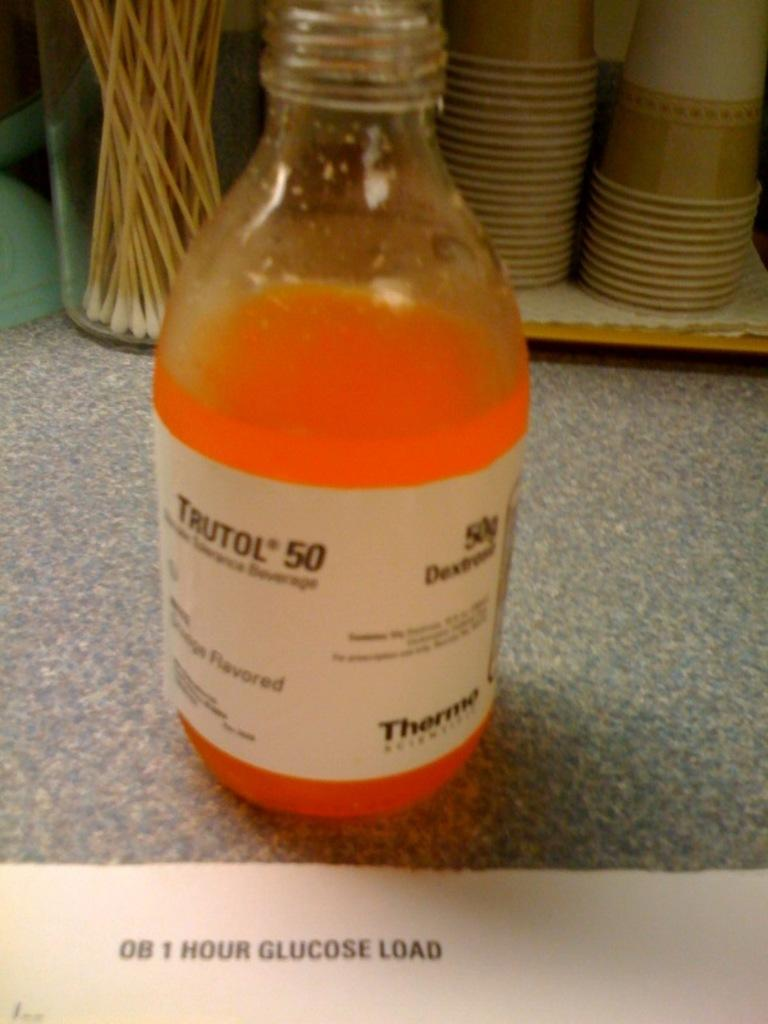<image>
Share a concise interpretation of the image provided. An opened bottle of Trutol 50 brand of drink from Thermo company is on the gray speckled table top. 